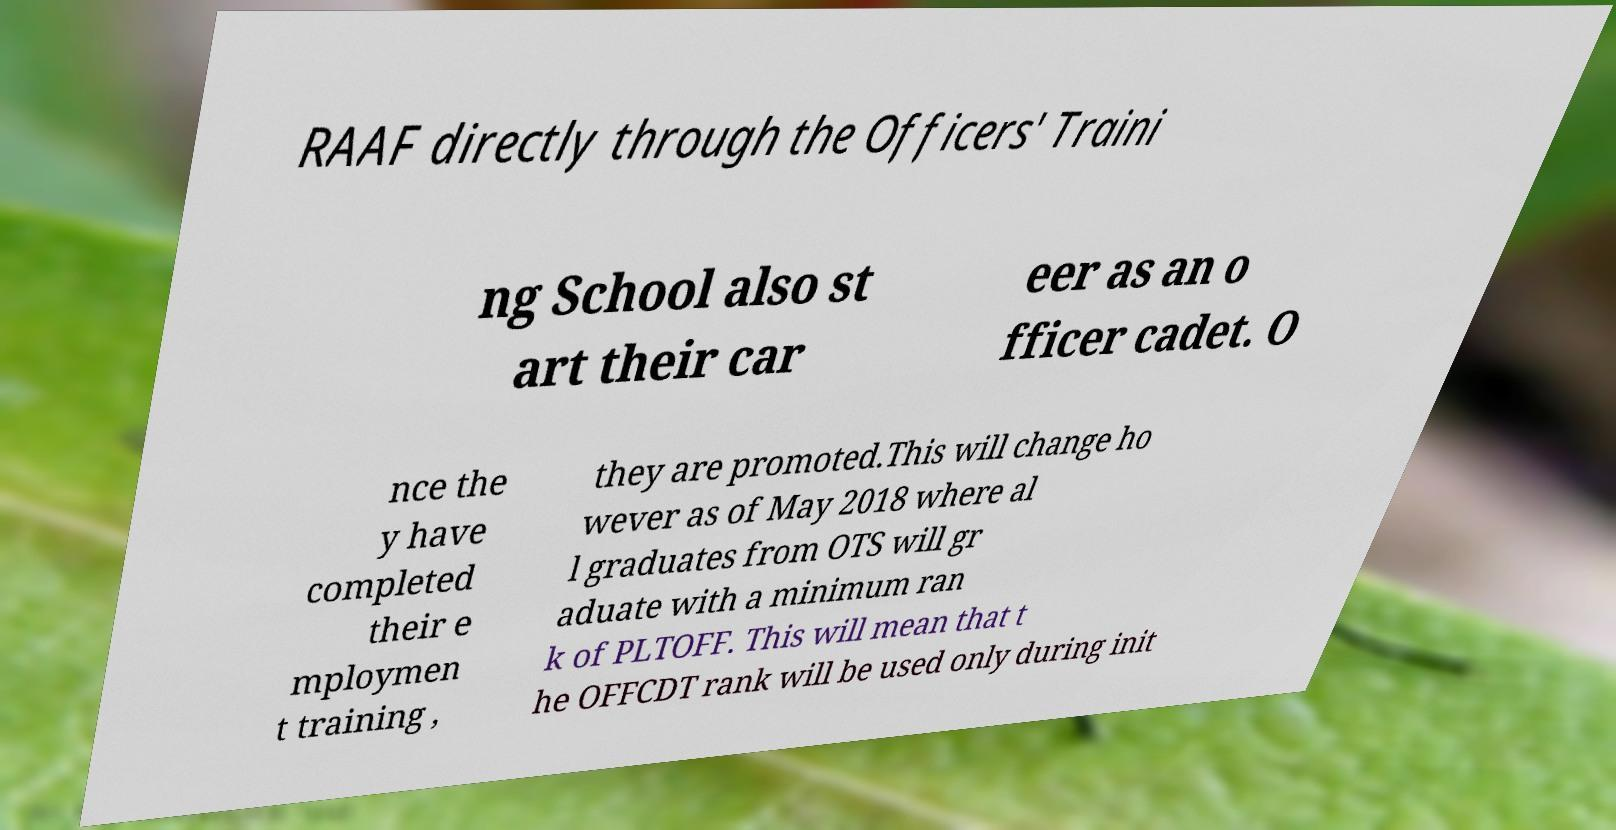Can you accurately transcribe the text from the provided image for me? RAAF directly through the Officers' Traini ng School also st art their car eer as an o fficer cadet. O nce the y have completed their e mploymen t training , they are promoted.This will change ho wever as of May 2018 where al l graduates from OTS will gr aduate with a minimum ran k of PLTOFF. This will mean that t he OFFCDT rank will be used only during init 